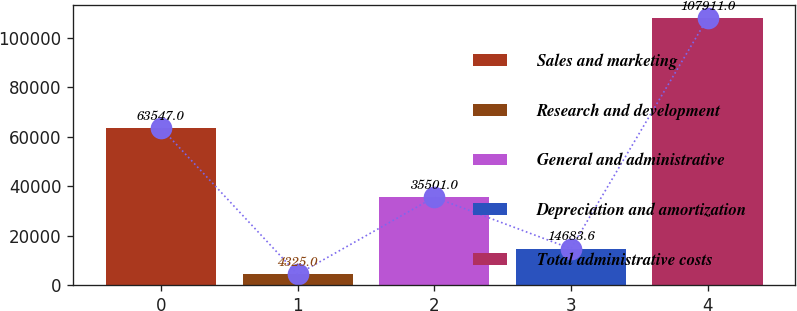Convert chart to OTSL. <chart><loc_0><loc_0><loc_500><loc_500><bar_chart><fcel>Sales and marketing<fcel>Research and development<fcel>General and administrative<fcel>Depreciation and amortization<fcel>Total administrative costs<nl><fcel>63547<fcel>4325<fcel>35501<fcel>14683.6<fcel>107911<nl></chart> 